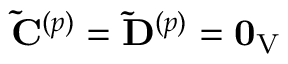<formula> <loc_0><loc_0><loc_500><loc_500>\tilde { C } ^ { ( p ) } = \tilde { D } ^ { ( p ) } = 0 _ { V }</formula> 